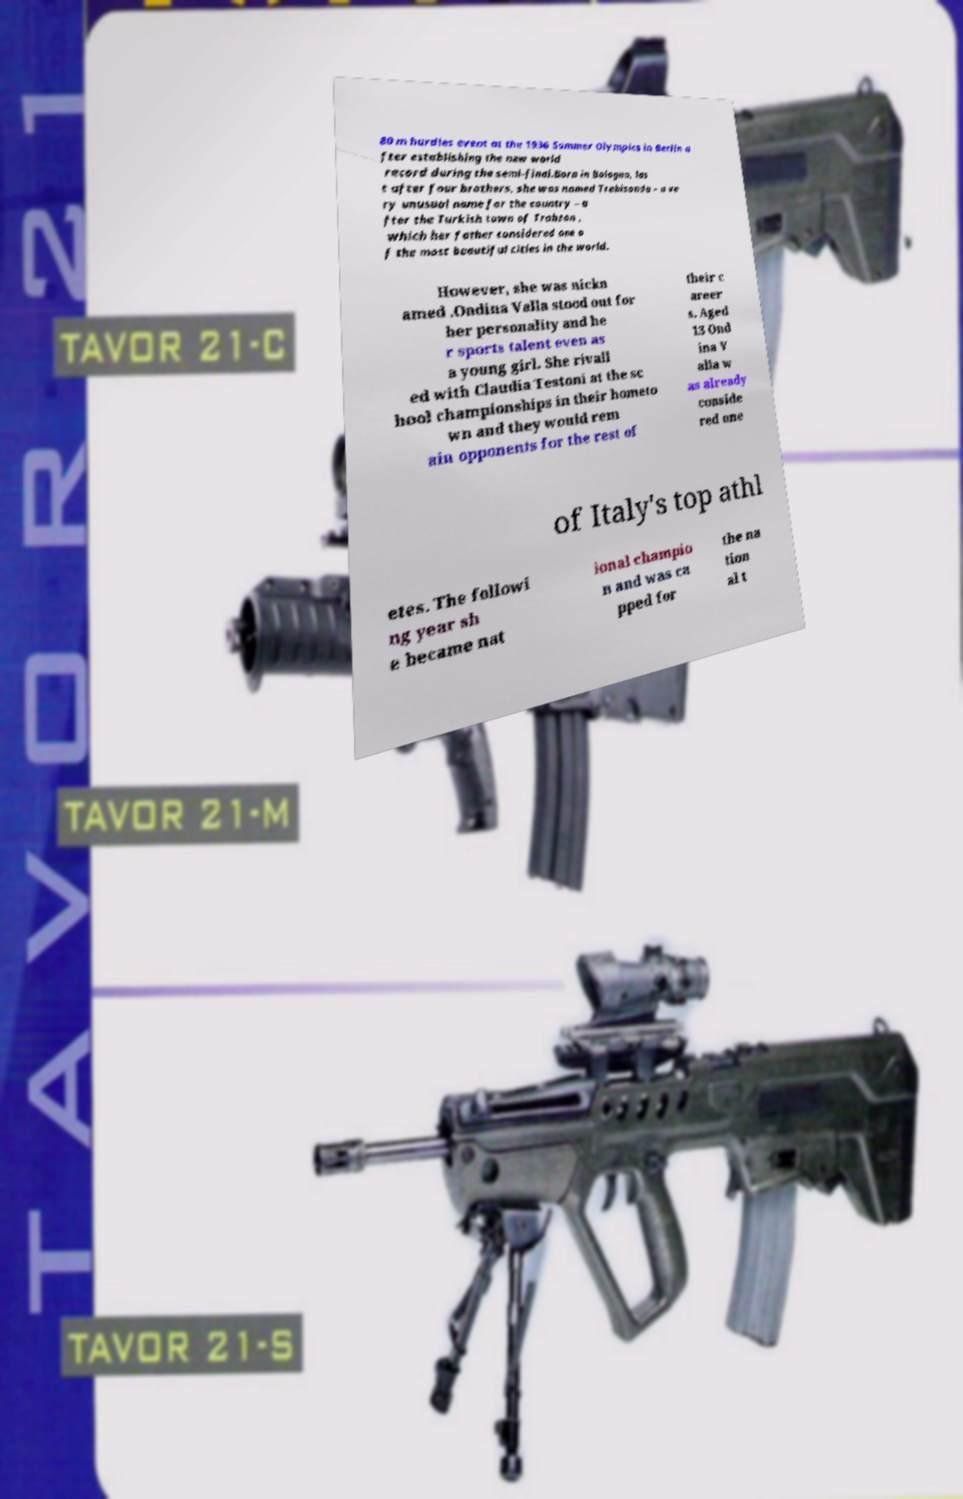For documentation purposes, I need the text within this image transcribed. Could you provide that? 80 m hurdles event at the 1936 Summer Olympics in Berlin a fter establishing the new world record during the semi-final.Born in Bologna, las t after four brothers, she was named Trebisonda – a ve ry unusual name for the country – a fter the Turkish town of Trabzon , which her father considered one o f the most beautiful cities in the world. However, she was nickn amed .Ondina Valla stood out for her personality and he r sports talent even as a young girl. She rivall ed with Claudia Testoni at the sc hool championships in their hometo wn and they would rem ain opponents for the rest of their c areer s. Aged 13 Ond ina V alla w as already conside red one of Italy's top athl etes. The followi ng year sh e became nat ional champio n and was ca pped for the na tion al t 